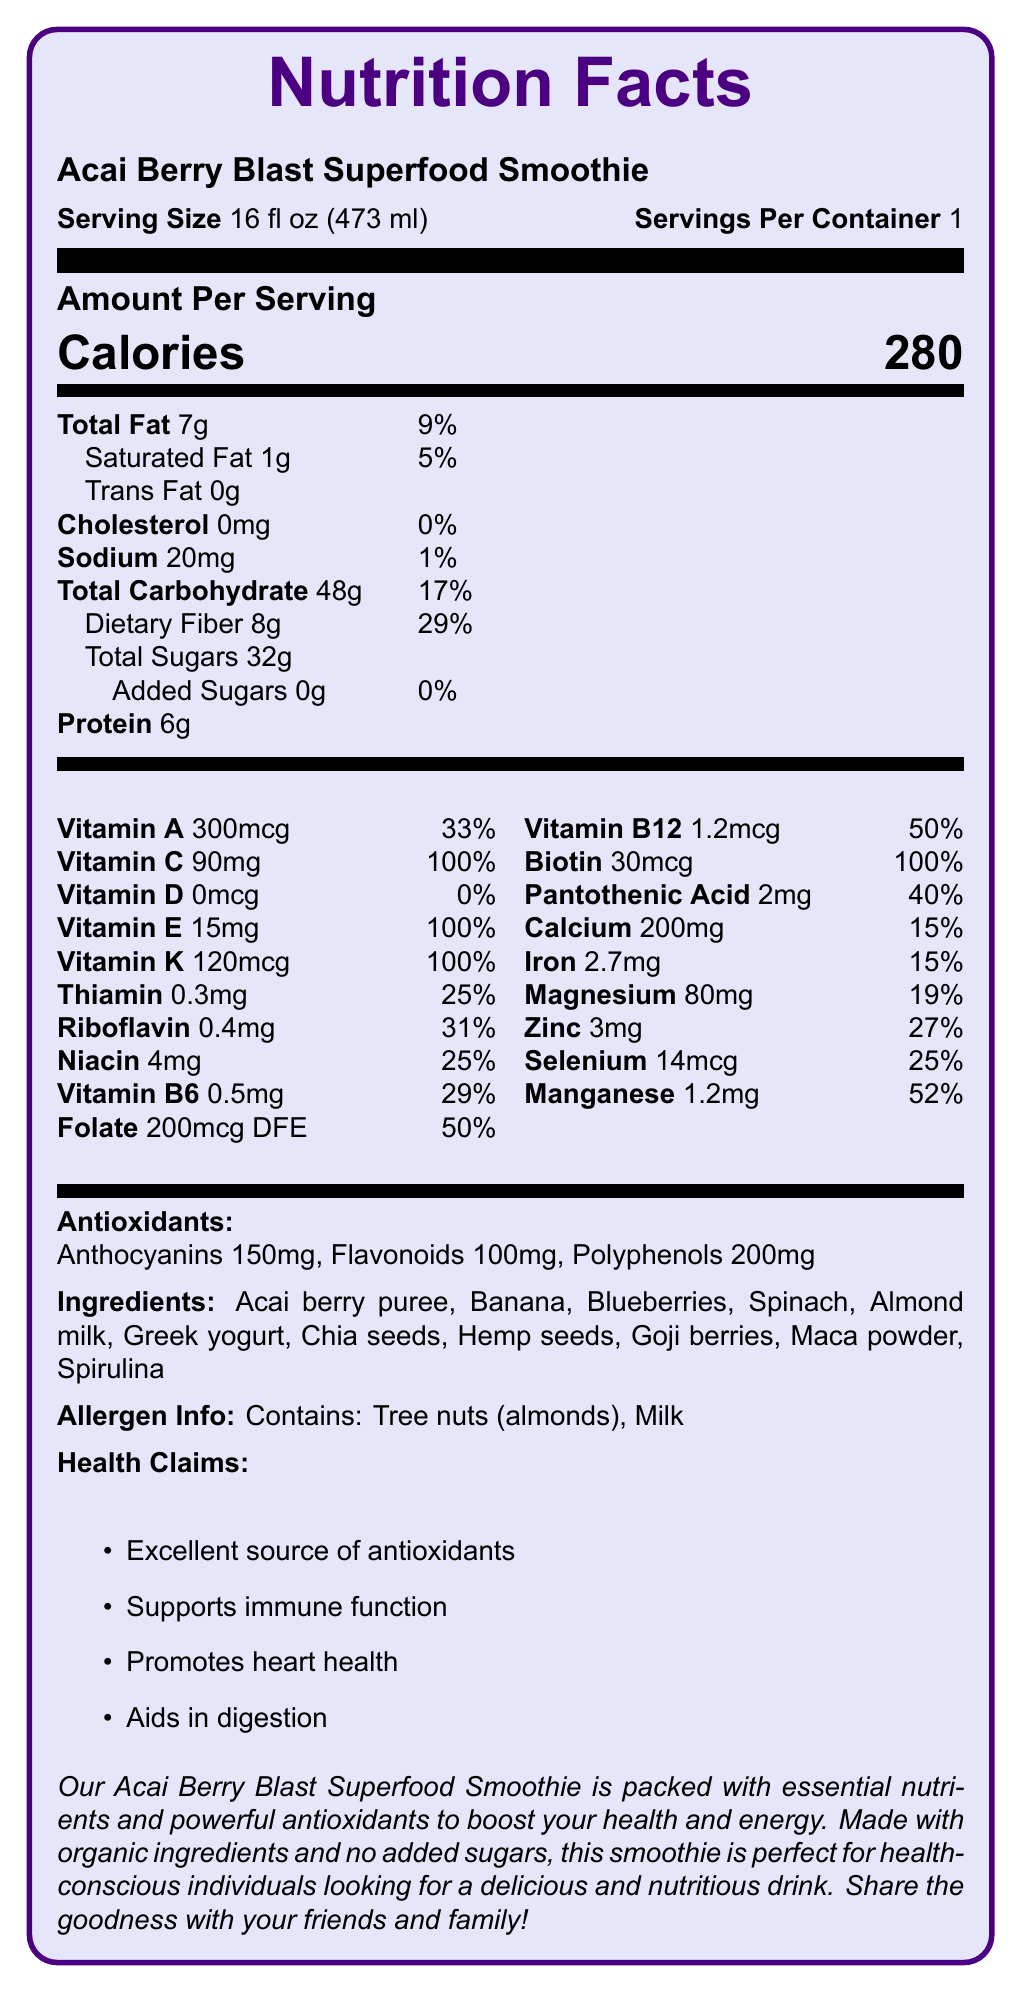what is the serving size of the Acai Berry Blast Superfood Smoothie? The serving size is clearly stated in the document as 16 fl oz (473 ml).
Answer: 16 fl oz (473 ml) How many calories are in one serving of the smoothie? The document specifies the amount per serving: Calories 280.
Answer: 280 What percentage of the daily value for vitamin C does the smoothie provide? According to the document, the smoothie provides 90mg of vitamin C, which is 100% of the daily value.
Answer: 100% What is the total amount of dietary fiber in one serving? The nutritional facts indicate that the smoothie contains 8g of dietary fiber per serving.
Answer: 8g What are the main ingredients in the smoothie? The ingredients are listed in the document under the "Ingredients" section.
Answer: Acai berry puree, Banana, Blueberries, Spinach, Almond milk, Greek yogurt, Chia seeds, Hemp seeds, Goji berries, Maca powder, Spirulina How many grams of protein are in the smoothie? The document specifies that the smoothie contains 6g of protein per serving.
Answer: 6g Which vitamin is NOT present in the smoothie? A. Vitamin D B. Vitamin A C. Vitamin E D. Vitamin C The document shows that the amount of vitamin D is 0mcg, which means it is not present in the smoothie.
Answer: A. Vitamin D What antioxidant has the highest concentration in the smoothie? A. Anthocyanins B. Flavonoids C. Polyphenols The document states that Polyphenols are present in 200mg, which is higher than the amounts for Anthocyanins and Flavonoids.
Answer: C. Polyphenols Does the smoothie contain any added sugars? The document specifies that the smoothie contains 0g of added sugars, indicating that there are no added sugars in the smoothie.
Answer: No Is this smoothie a good source of antioxidants? The health claims specify that it is an excellent source of antioxidants.
Answer: Yes Summarize the main idea of the document. The document comprehensively outlines the nutritional content, health benefits, and ingredients of the Acai Berry Blast Superfood Smoothie, presenting it as a nutritious option for health-conscious individuals.
Answer: The Acai Berry Blast Superfood Smoothie is a nutrient-dense drink featuring a detailed breakdown of vitamins and antioxidants. It contains 280 calories per serving with notable amounts of vitamins C, E, K, and B-complex vitamins. The smoothie includes various organic ingredients and promotes several health benefits, such as immune support and heart health. It also contains no added sugars and is noted for its high antioxidant content, with specific antioxidants listed. The document also addresses allergen information. How many milligrams of calcium are in one serving? The nutritional facts indicate that the smoothie contains 200mg of calcium per serving.
Answer: 200mg What is the daily value percentage of manganese in the smoothie? The document specifies that the daily value percentage for manganese is 52%.
Answer: 52% How much iron does one serving of the smoothie provide? According to the document, each serving contains 2.7mg of iron.
Answer: 2.7mg Can I determine the price of the smoothie from this document? The document does not provide any information regarding the price of the smoothie.
Answer: Cannot be determined 